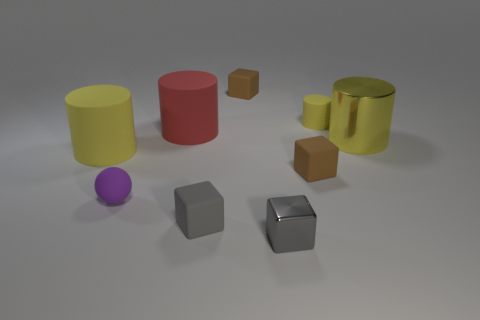Subtract all gray balls. How many yellow cylinders are left? 3 Subtract all green cylinders. Subtract all brown balls. How many cylinders are left? 4 Add 1 small brown matte cubes. How many objects exist? 10 Subtract all cylinders. How many objects are left? 5 Subtract all rubber blocks. Subtract all tiny yellow cylinders. How many objects are left? 5 Add 4 small gray matte objects. How many small gray matte objects are left? 5 Add 8 gray objects. How many gray objects exist? 10 Subtract 0 purple cubes. How many objects are left? 9 